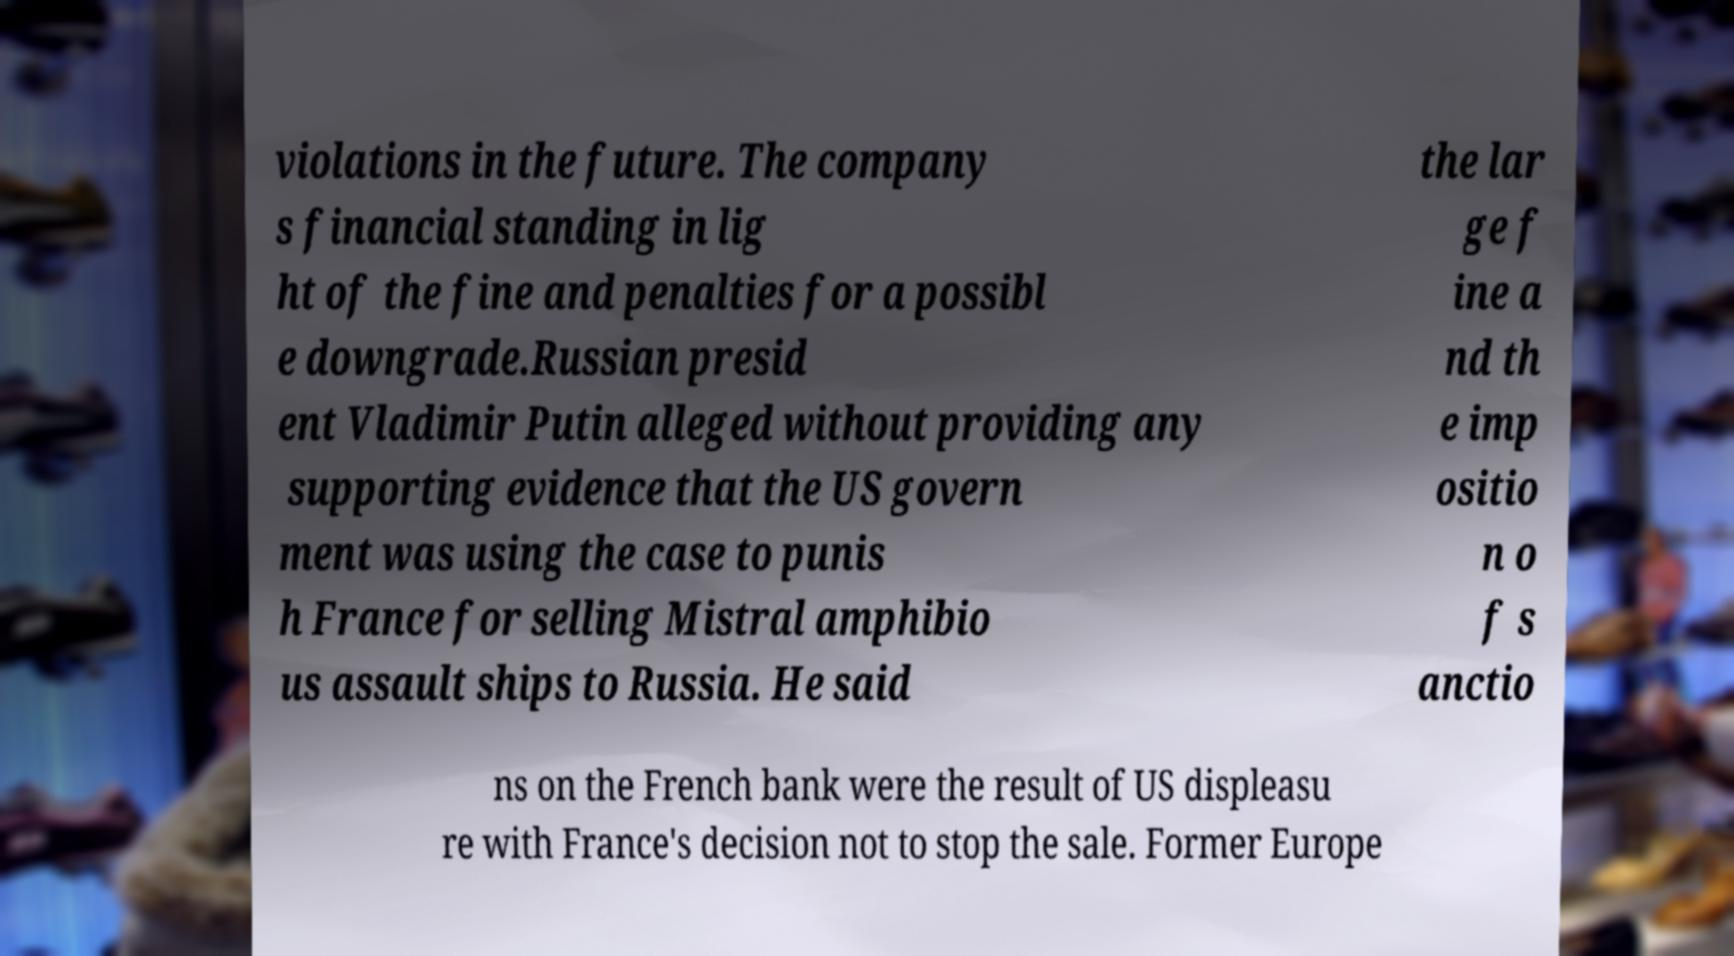Please identify and transcribe the text found in this image. violations in the future. The company s financial standing in lig ht of the fine and penalties for a possibl e downgrade.Russian presid ent Vladimir Putin alleged without providing any supporting evidence that the US govern ment was using the case to punis h France for selling Mistral amphibio us assault ships to Russia. He said the lar ge f ine a nd th e imp ositio n o f s anctio ns on the French bank were the result of US displeasu re with France's decision not to stop the sale. Former Europe 